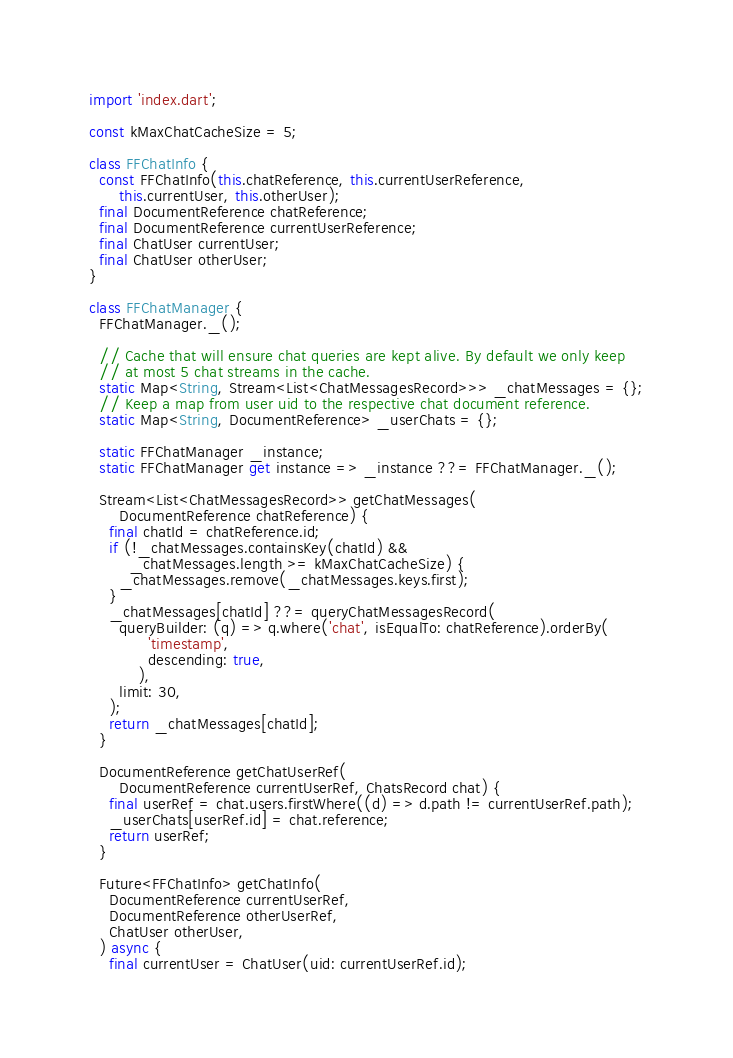<code> <loc_0><loc_0><loc_500><loc_500><_Dart_>import 'index.dart';

const kMaxChatCacheSize = 5;

class FFChatInfo {
  const FFChatInfo(this.chatReference, this.currentUserReference,
      this.currentUser, this.otherUser);
  final DocumentReference chatReference;
  final DocumentReference currentUserReference;
  final ChatUser currentUser;
  final ChatUser otherUser;
}

class FFChatManager {
  FFChatManager._();

  // Cache that will ensure chat queries are kept alive. By default we only keep
  // at most 5 chat streams in the cache.
  static Map<String, Stream<List<ChatMessagesRecord>>> _chatMessages = {};
  // Keep a map from user uid to the respective chat document reference.
  static Map<String, DocumentReference> _userChats = {};

  static FFChatManager _instance;
  static FFChatManager get instance => _instance ??= FFChatManager._();

  Stream<List<ChatMessagesRecord>> getChatMessages(
      DocumentReference chatReference) {
    final chatId = chatReference.id;
    if (!_chatMessages.containsKey(chatId) &&
        _chatMessages.length >= kMaxChatCacheSize) {
      _chatMessages.remove(_chatMessages.keys.first);
    }
    _chatMessages[chatId] ??= queryChatMessagesRecord(
      queryBuilder: (q) => q.where('chat', isEqualTo: chatReference).orderBy(
            'timestamp',
            descending: true,
          ),
      limit: 30,
    );
    return _chatMessages[chatId];
  }

  DocumentReference getChatUserRef(
      DocumentReference currentUserRef, ChatsRecord chat) {
    final userRef = chat.users.firstWhere((d) => d.path != currentUserRef.path);
    _userChats[userRef.id] = chat.reference;
    return userRef;
  }

  Future<FFChatInfo> getChatInfo(
    DocumentReference currentUserRef,
    DocumentReference otherUserRef,
    ChatUser otherUser,
  ) async {
    final currentUser = ChatUser(uid: currentUserRef.id);</code> 